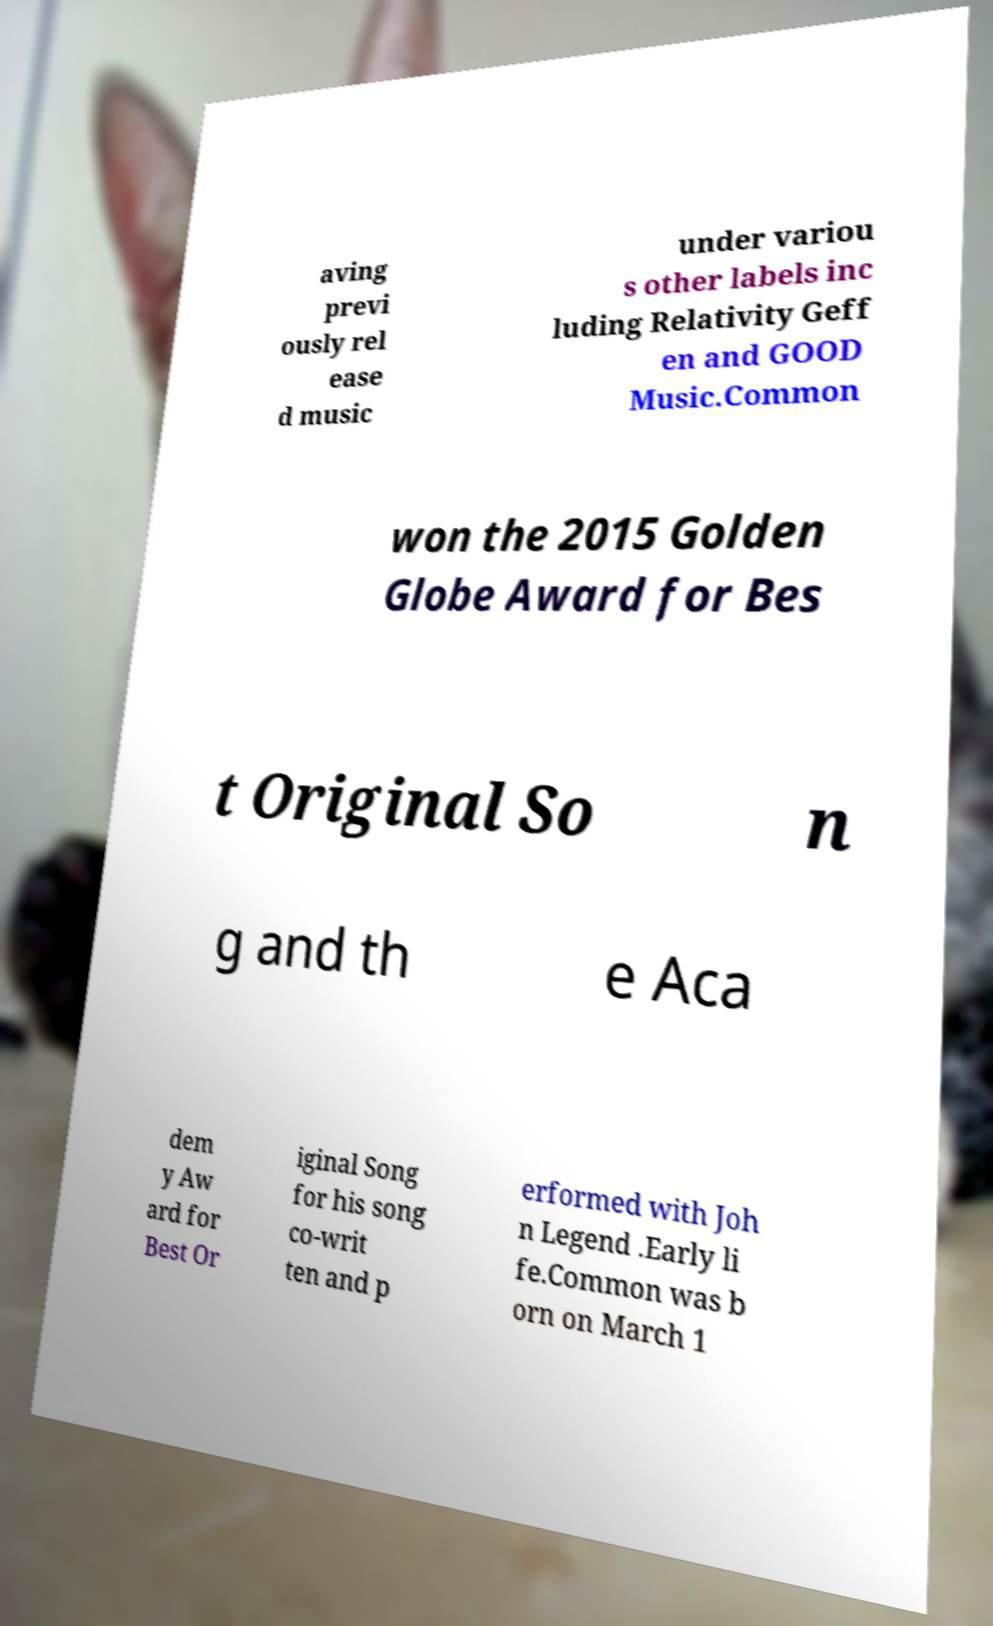Can you accurately transcribe the text from the provided image for me? aving previ ously rel ease d music under variou s other labels inc luding Relativity Geff en and GOOD Music.Common won the 2015 Golden Globe Award for Bes t Original So n g and th e Aca dem y Aw ard for Best Or iginal Song for his song co-writ ten and p erformed with Joh n Legend .Early li fe.Common was b orn on March 1 